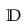Convert formula to latex. <formula><loc_0><loc_0><loc_500><loc_500>\mathbb { D }</formula> 